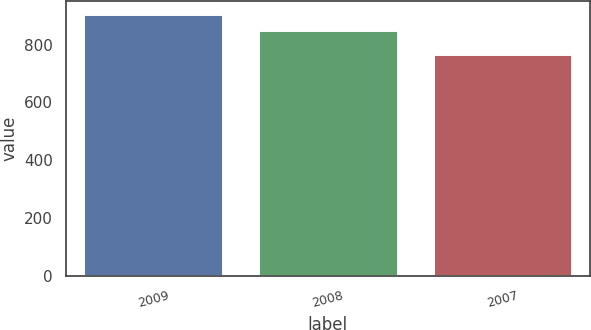Convert chart. <chart><loc_0><loc_0><loc_500><loc_500><bar_chart><fcel>2009<fcel>2008<fcel>2007<nl><fcel>905<fcel>850<fcel>766<nl></chart> 